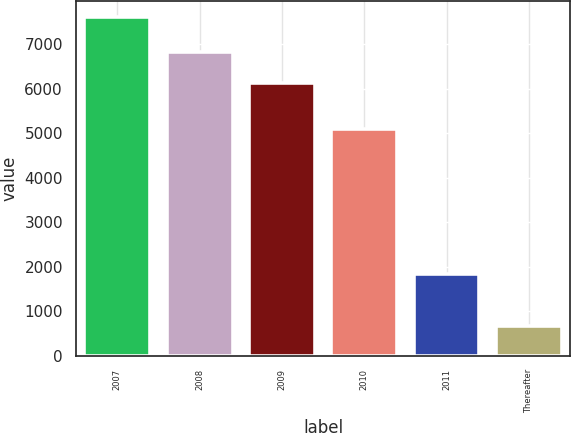Convert chart to OTSL. <chart><loc_0><loc_0><loc_500><loc_500><bar_chart><fcel>2007<fcel>2008<fcel>2009<fcel>2010<fcel>2011<fcel>Thereafter<nl><fcel>7600<fcel>6824.6<fcel>6131<fcel>5090<fcel>1834<fcel>664<nl></chart> 